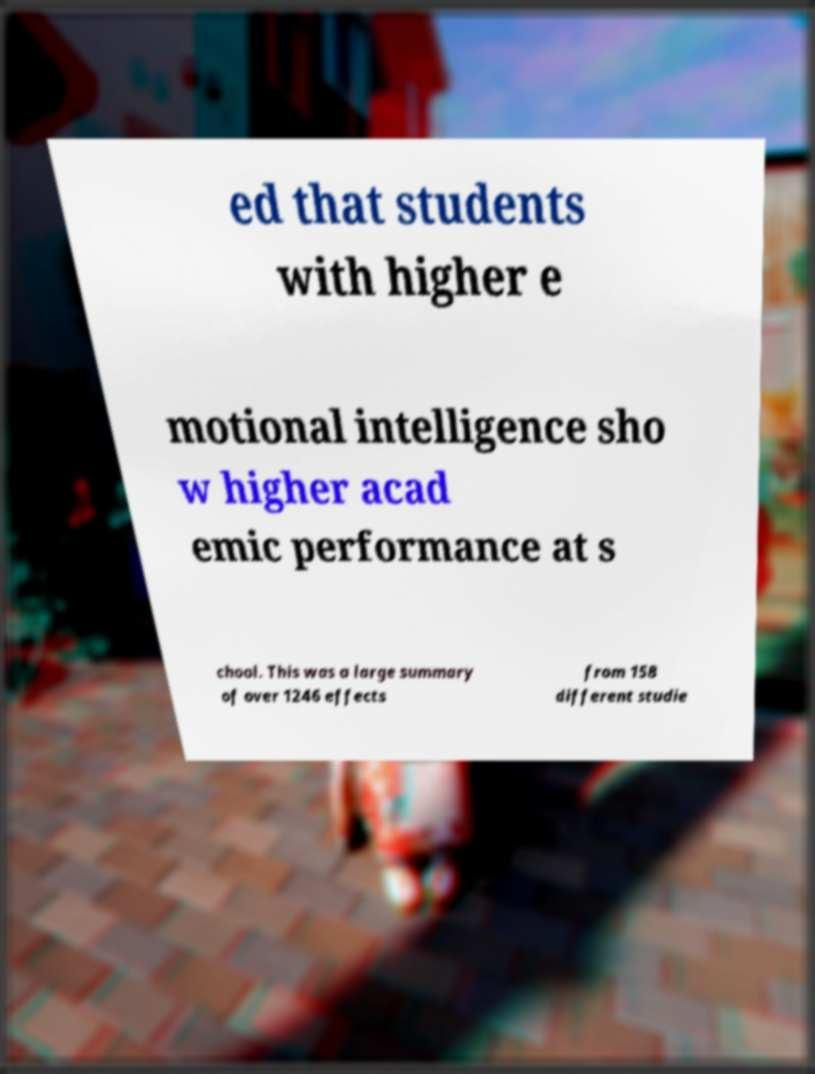Could you extract and type out the text from this image? ed that students with higher e motional intelligence sho w higher acad emic performance at s chool. This was a large summary of over 1246 effects from 158 different studie 